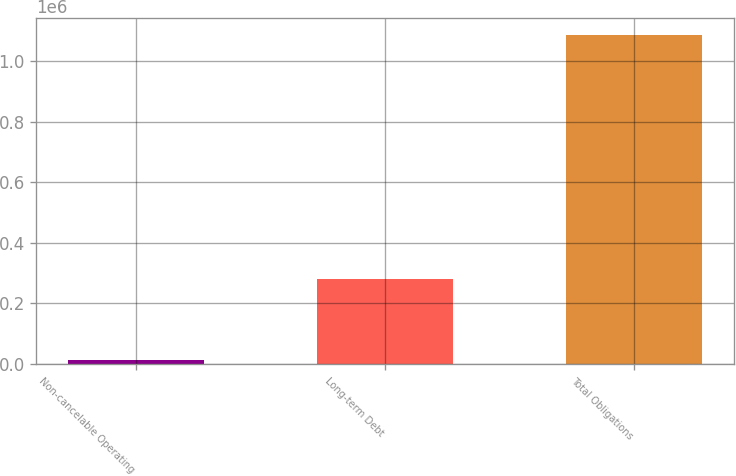Convert chart to OTSL. <chart><loc_0><loc_0><loc_500><loc_500><bar_chart><fcel>Non-cancelable Operating<fcel>Long-term Debt<fcel>Total Obligations<nl><fcel>12579<fcel>279043<fcel>1.08812e+06<nl></chart> 